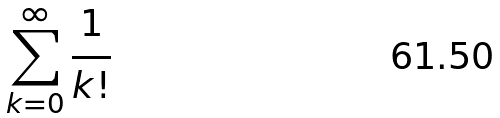<formula> <loc_0><loc_0><loc_500><loc_500>\sum _ { k = 0 } ^ { \infty } \frac { 1 } { k ! }</formula> 